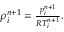Convert formula to latex. <formula><loc_0><loc_0><loc_500><loc_500>\begin{array} { r } { \rho _ { i } ^ { n + 1 } = \frac { p _ { i } ^ { n + 1 } } { R T _ { i } ^ { n + 1 } } . } \end{array}</formula> 